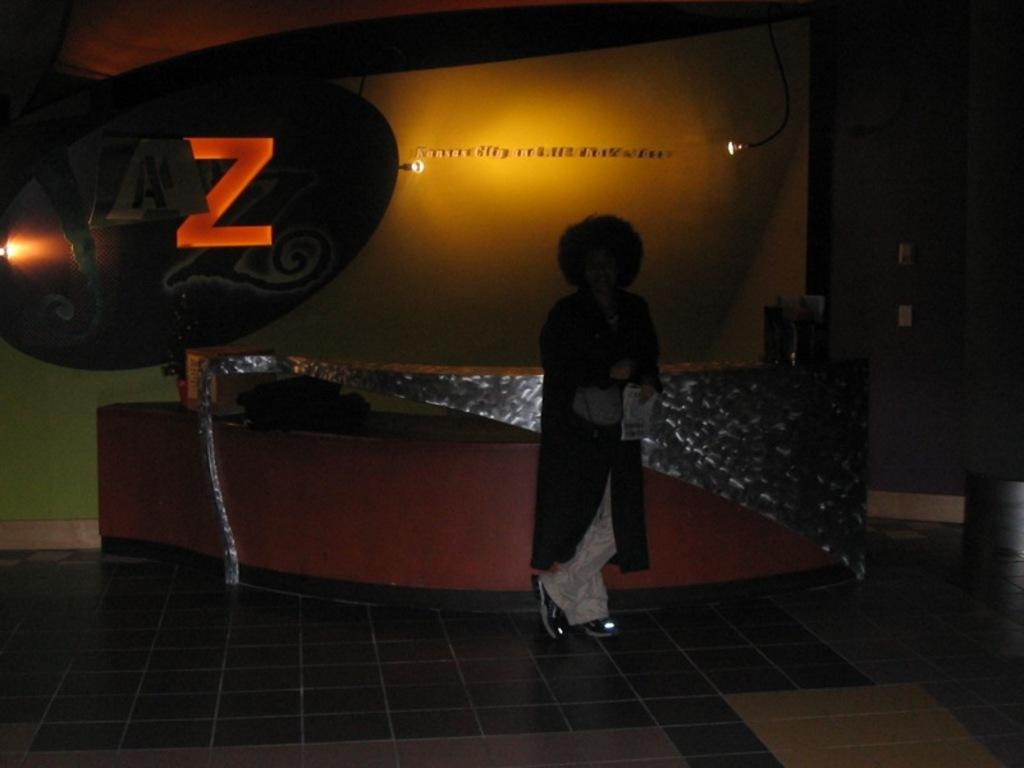How would you summarize this image in a sentence or two? In the foreground of the image we can see floor. In the middle of the image we can see a person is standing near a desk. On the top of the image we can see lights and a text on the wall. 